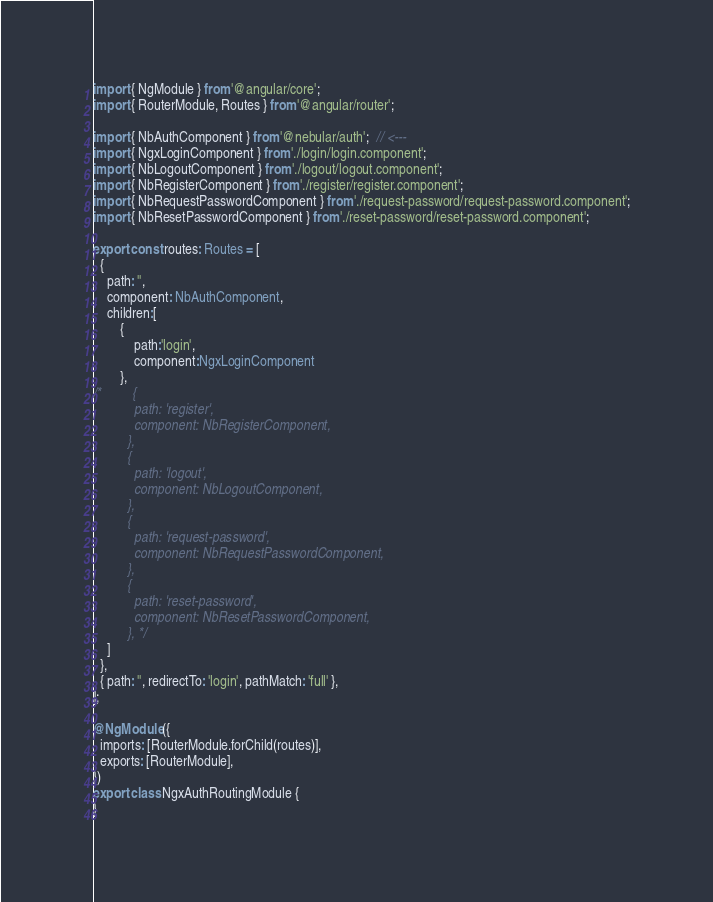<code> <loc_0><loc_0><loc_500><loc_500><_TypeScript_>import { NgModule } from '@angular/core';
import { RouterModule, Routes } from '@angular/router';

import { NbAuthComponent } from '@nebular/auth';  // <---
import { NgxLoginComponent } from './login/login.component';
import { NbLogoutComponent } from './logout/logout.component';
import { NbRegisterComponent } from './register/register.component';
import { NbRequestPasswordComponent } from './request-password/request-password.component';
import { NbResetPasswordComponent } from './reset-password/reset-password.component';

export const routes: Routes = [
  {
    path: '',
    component: NbAuthComponent,  
    children:[
        {
            path:'login',
            component:NgxLoginComponent
        },
/*         {
            path: 'register',
            component: NbRegisterComponent,
          },
          {
            path: 'logout',
            component: NbLogoutComponent,
          },
          {
            path: 'request-password',
            component: NbRequestPasswordComponent,
          },
          {
            path: 'reset-password',
            component: NbResetPasswordComponent,
          }, */
    ]
  },
  { path: '', redirectTo: 'login', pathMatch: 'full' },
];

@NgModule({
  imports: [RouterModule.forChild(routes)],
  exports: [RouterModule],
})
export class NgxAuthRoutingModule {
}</code> 